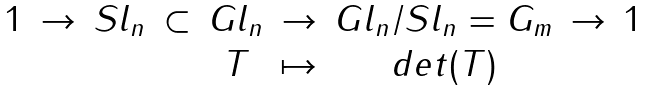Convert formula to latex. <formula><loc_0><loc_0><loc_500><loc_500>\begin{matrix} 1 & \to & S l _ { n } & \subset & G l _ { n } & \to & G l _ { n } / S l _ { n } = G _ { m } & \to & 1 \\ & & & & T & \mapsto & d e t ( T ) & & \end{matrix}</formula> 